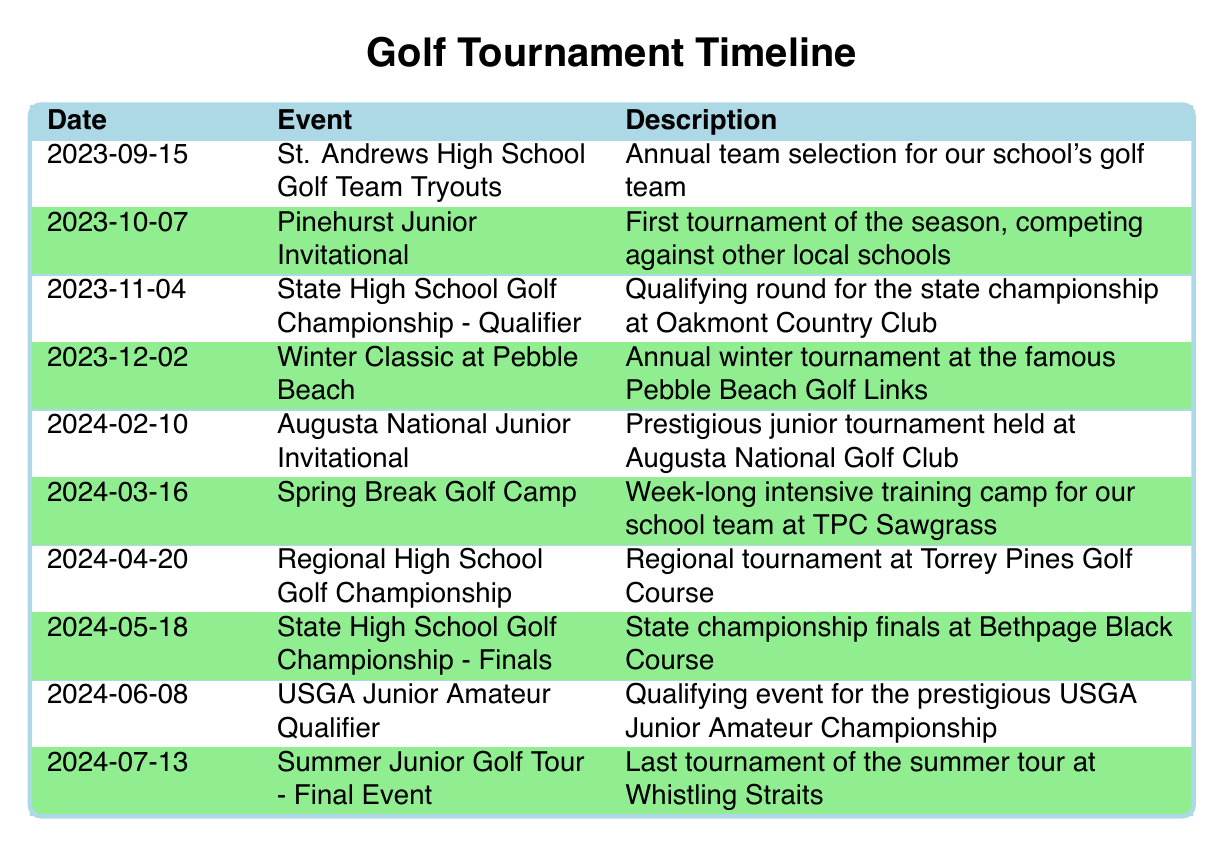What is the date of the Pinehurst Junior Invitational? The table shows that the Pinehurst Junior Invitational is listed under the event column, and its corresponding date is mentioned in the date column. Therefore, the date is 2023-10-07.
Answer: 2023-10-07 How many tournaments are scheduled before the State High School Golf Championship - Finals? Looking at the events listed before the State High School Golf Championship - Finals on 2024-05-18, we can identify four tournaments: Pinehurst Junior Invitational, State High School Golf Championship - Qualifier, Winter Classic at Pebble Beach, and Augusta National Junior Invitational. Thus, there are four tournaments scheduled before this event.
Answer: 4 Is the Winter Classic at Pebble Beach the last event before any qualifiers? To determine this, we check the sequence of events leading up to any qualifiers. The Winter Classic at Pebble Beach occurs on 2023-12-02, and the next event is the Augusta National Junior Invitational on 2024-02-10, which is not a qualifier; however, the USGA Junior Amateur Qualifier on 2024-06-08 is indeed a qualifier after several events. Thus, the claim is false.
Answer: No How many months are there between the Pinehurst Junior Invitational and the Augusta National Junior Invitational? The Pinehurst Junior Invitational is on 2023-10-07 and the Augusta National Junior Invitational is on 2024-02-10. October to February spans four months. Therefore, the number of months between these events is four.
Answer: 4 Which tournament occurs closest to the Spring Break Golf Camp? The Spring Break Golf Camp is scheduled for 2024-03-16. By examining the events listed just before and after it, the Regional High School Golf Championship is on 2024-04-20, which is a month later. The most recent event before it is Augusta National Junior Invitational on 2024-02-10. Hence, the closest tournament is the Augusta National Junior Invitational.
Answer: Augusta National Junior Invitational 